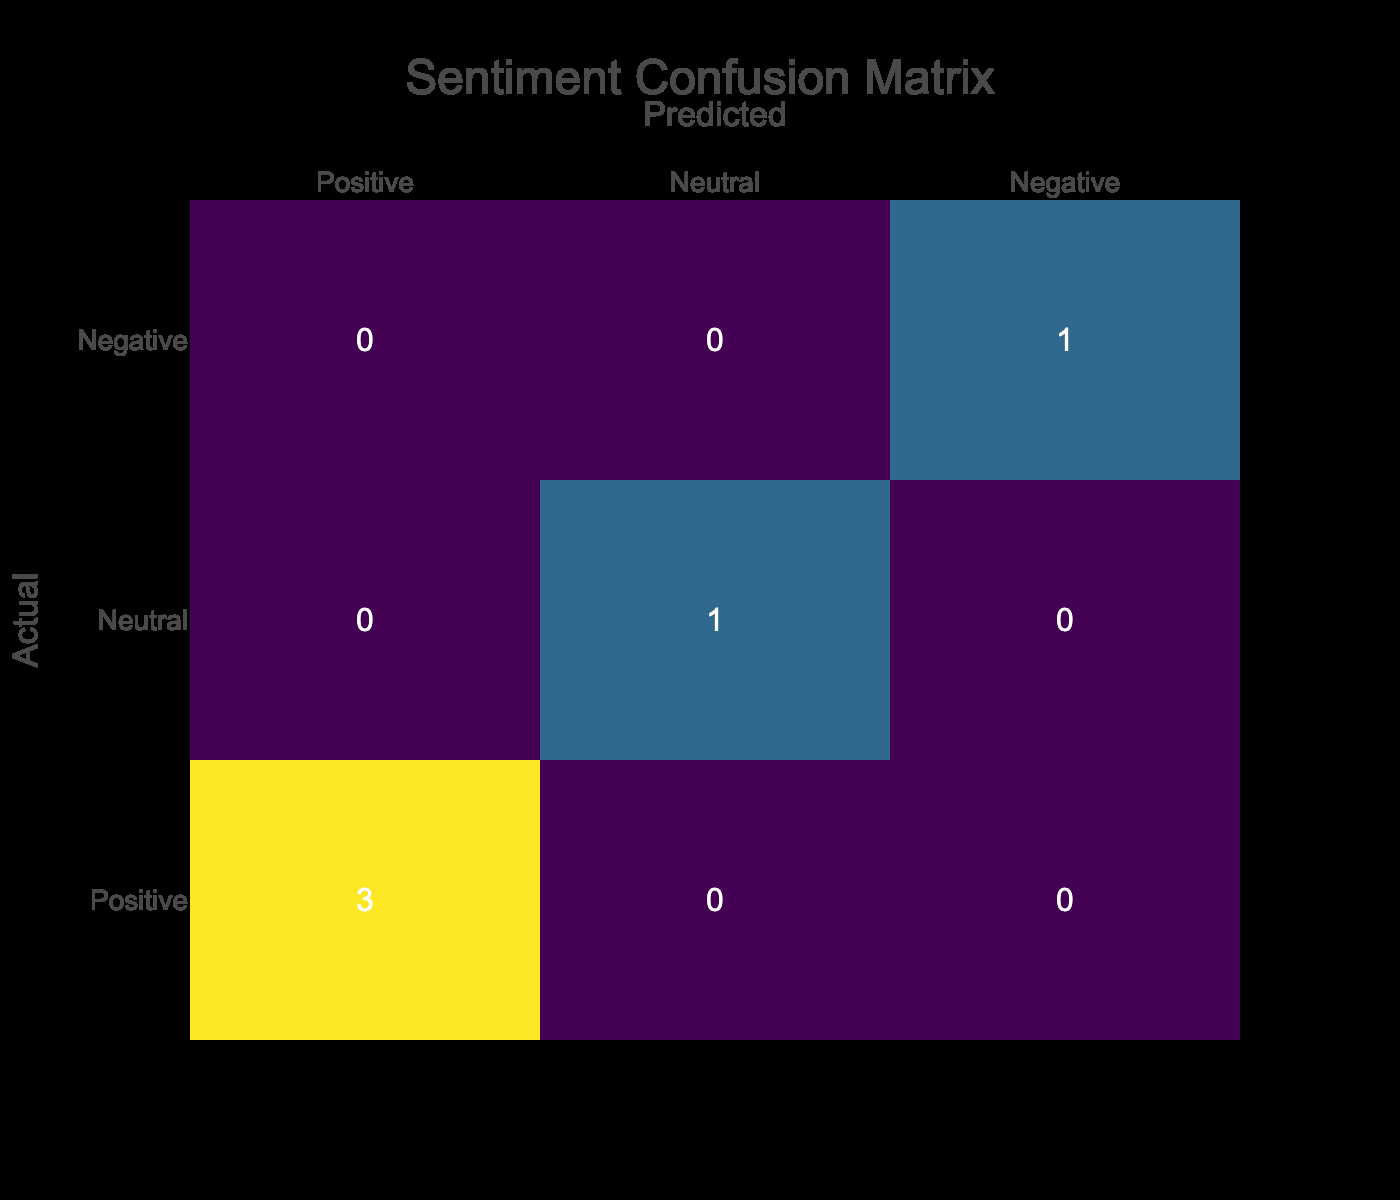What is the count of positive reviews? In the confusion matrix, there is one row labeled "Positive." Referring to the count in this row, it shows 3 occurrences of positive sentiment reviews.
Answer: 3 What is the count of neutral reviews? In the confusion matrix, the row labeled "Neutral" shows 1 occurrence of neutral sentiment reviews.
Answer: 1 Is there any review labeled as negative? The confusion matrix has a row labeled "Negative," which indicates that there are 1 occurrence of negative sentiment reviews. This confirms that yes, there are negative reviews present.
Answer: Yes What is the total number of reviews represented in the table? To find the total number of reviews, we can look at the sums of all sentiment counts in the confusion matrix. The counts are 3 (Positive) + 1 (Neutral) + 1 (Negative) = 5.
Answer: 5 How many more positive reviews are there than negative reviews? From the confusion matrix, the count of positive reviews is 3 and negative reviews is 1. The difference is 3 (Positive) - 1 (Negative) = 2.
Answer: 2 Are there more positive reviews than neutral reviews? The confusion matrix shows 3 positive reviews and 1 neutral review. Comparing these values indicates that 3 is indeed greater than 1. Thus, the answer is yes.
Answer: Yes What's the ratio of negative to positive reviews? The count of negative reviews is 1, and the count of positive reviews is 3. To find the ratio, we take 1 (Negative) : 3 (Positive), which simplifies to 1:3.
Answer: 1:3 If we only consider positive and neutral reviews, what percentage of the total does each represent? The total count considering only positive (3) and neutral (1) is 4. The percentage of positive is (3/4)*100 = 75%, and for neutral it's (1/4)*100 = 25%. Therefore, positive reviews represent 75% and neutral reviews represent 25%.
Answer: Positive: 75%, Neutral: 25% What is the sentiment classification balance among the reviews? The balance can be assessed by comparing the counts: Positive = 3, Neutral = 1, Negative = 1. Positive sentiment is the most common, followed by neutral and negative being equal; hence the classification is skewed towards positive reviews.
Answer: Skewed towards positive reviews 